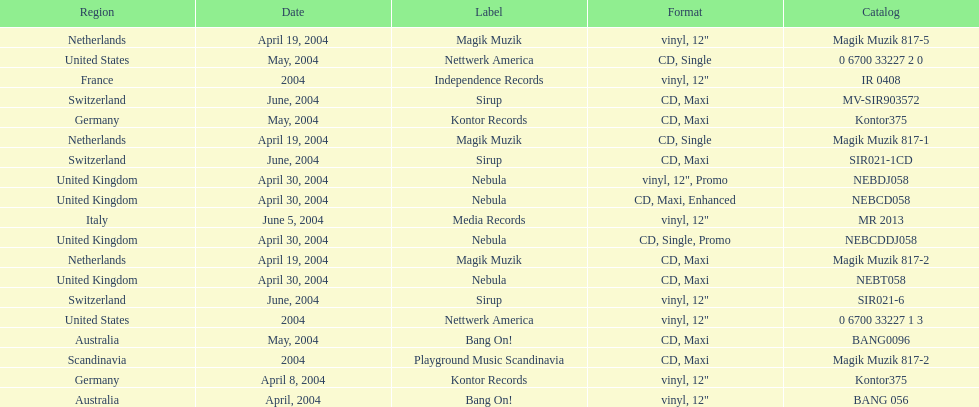How many catalogs were released? 19. 